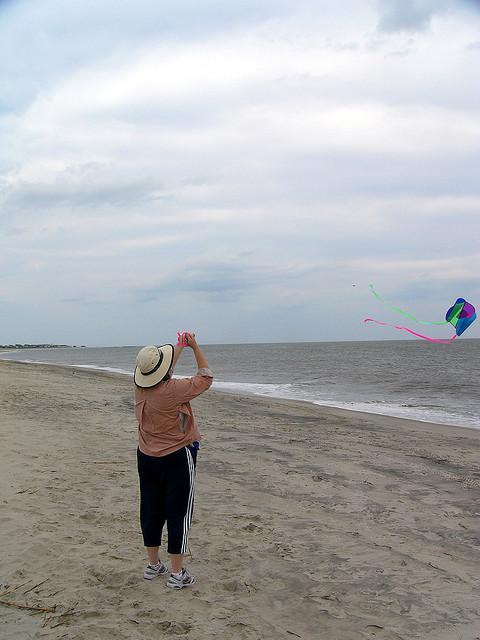How many kites are flying?
Give a very brief answer. 1. 